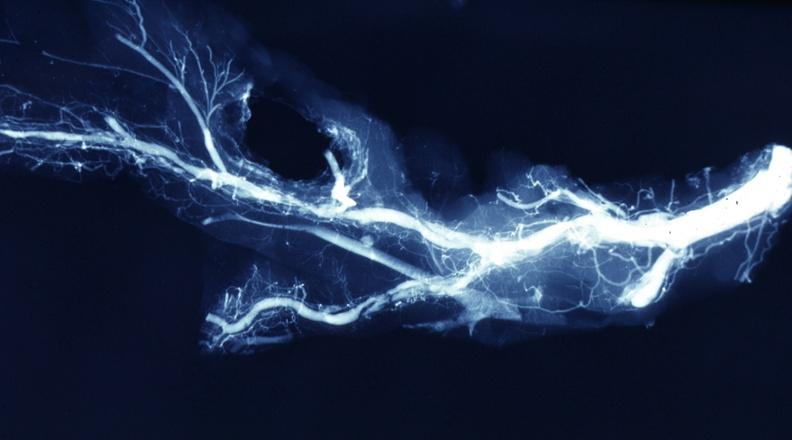what is present?
Answer the question using a single word or phrase. Cardiovascular 